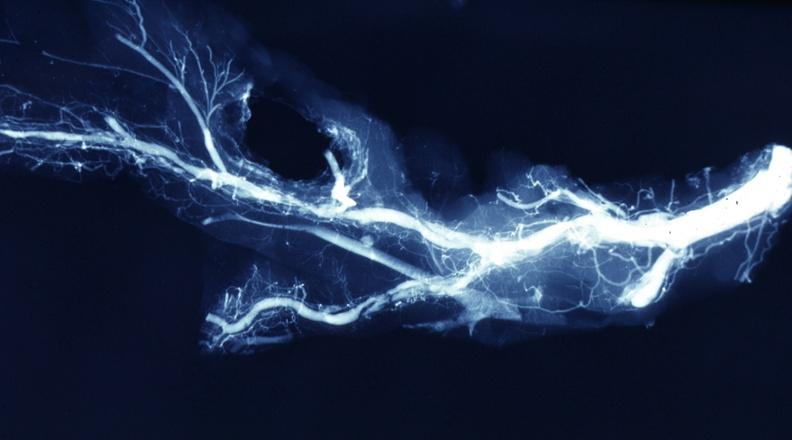what is present?
Answer the question using a single word or phrase. Cardiovascular 